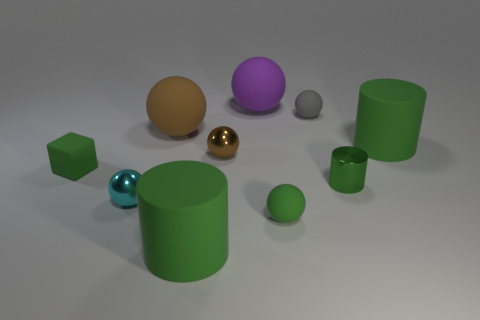How many green cylinders must be subtracted to get 1 green cylinders? 2 Subtract all shiny cylinders. How many cylinders are left? 2 Subtract all brown cubes. How many brown balls are left? 2 Subtract 1 cylinders. How many cylinders are left? 2 Subtract all brown balls. How many balls are left? 4 Subtract all red balls. Subtract all yellow cylinders. How many balls are left? 6 Add 2 big things. How many big things exist? 6 Subtract 0 gray cylinders. How many objects are left? 10 Subtract all spheres. How many objects are left? 4 Subtract all small metallic objects. Subtract all brown matte balls. How many objects are left? 6 